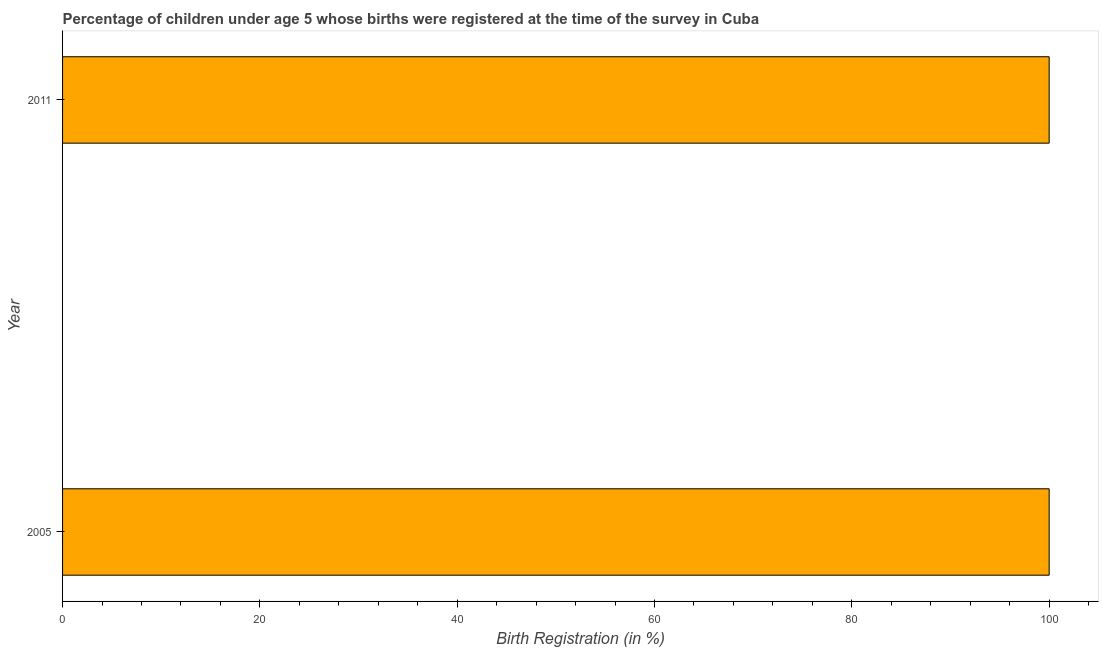Does the graph contain grids?
Ensure brevity in your answer.  No. What is the title of the graph?
Your answer should be very brief. Percentage of children under age 5 whose births were registered at the time of the survey in Cuba. What is the label or title of the X-axis?
Give a very brief answer. Birth Registration (in %). What is the label or title of the Y-axis?
Give a very brief answer. Year. In how many years, is the birth registration greater than 40 %?
Ensure brevity in your answer.  2. Is the birth registration in 2005 less than that in 2011?
Give a very brief answer. No. In how many years, is the birth registration greater than the average birth registration taken over all years?
Ensure brevity in your answer.  0. How many bars are there?
Provide a succinct answer. 2. Are all the bars in the graph horizontal?
Give a very brief answer. Yes. How many years are there in the graph?
Offer a very short reply. 2. What is the difference between two consecutive major ticks on the X-axis?
Your response must be concise. 20. Are the values on the major ticks of X-axis written in scientific E-notation?
Offer a very short reply. No. What is the Birth Registration (in %) in 2005?
Keep it short and to the point. 100. 